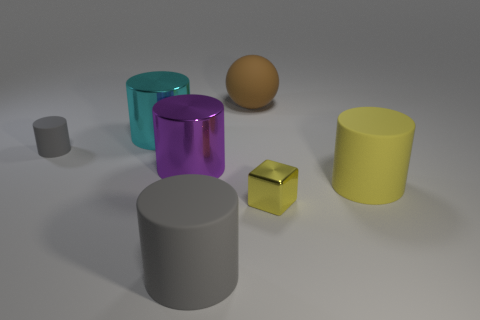If these objects were part of a still life painting, what mood might the artist be conveying? If interpreted as a still life painting, the neutral background and the clean, unadorned shapes could suggest a mood of calmness and simplicity, focusing on form and light rather than narrative. 